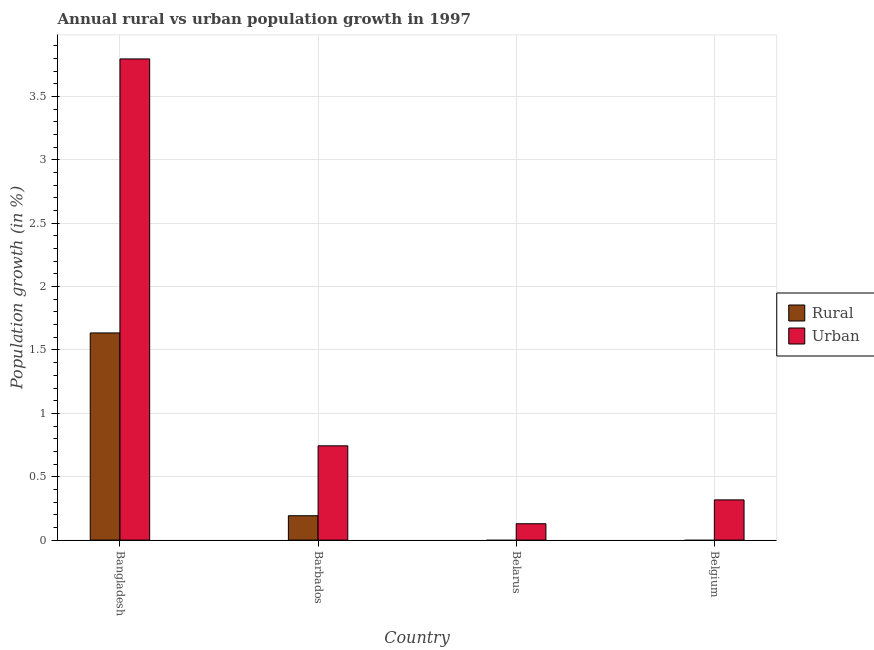How many different coloured bars are there?
Provide a short and direct response. 2. What is the label of the 2nd group of bars from the left?
Provide a short and direct response. Barbados. What is the rural population growth in Belgium?
Your answer should be compact. 0. Across all countries, what is the maximum urban population growth?
Make the answer very short. 3.8. In which country was the rural population growth maximum?
Your answer should be very brief. Bangladesh. What is the total urban population growth in the graph?
Give a very brief answer. 4.99. What is the difference between the urban population growth in Bangladesh and that in Barbados?
Your answer should be very brief. 3.05. What is the difference between the rural population growth in Belarus and the urban population growth in Belgium?
Keep it short and to the point. -0.32. What is the average urban population growth per country?
Your answer should be very brief. 1.25. What is the difference between the urban population growth and rural population growth in Bangladesh?
Keep it short and to the point. 2.16. What is the ratio of the rural population growth in Bangladesh to that in Barbados?
Your answer should be very brief. 8.5. What is the difference between the highest and the second highest urban population growth?
Offer a terse response. 3.05. What is the difference between the highest and the lowest rural population growth?
Your response must be concise. 1.63. In how many countries, is the urban population growth greater than the average urban population growth taken over all countries?
Your answer should be compact. 1. Is the sum of the urban population growth in Belarus and Belgium greater than the maximum rural population growth across all countries?
Provide a short and direct response. No. What is the difference between two consecutive major ticks on the Y-axis?
Ensure brevity in your answer.  0.5. Where does the legend appear in the graph?
Offer a very short reply. Center right. How many legend labels are there?
Your response must be concise. 2. How are the legend labels stacked?
Your answer should be very brief. Vertical. What is the title of the graph?
Keep it short and to the point. Annual rural vs urban population growth in 1997. Does "National Tourists" appear as one of the legend labels in the graph?
Give a very brief answer. No. What is the label or title of the X-axis?
Your answer should be compact. Country. What is the label or title of the Y-axis?
Keep it short and to the point. Population growth (in %). What is the Population growth (in %) in Rural in Bangladesh?
Give a very brief answer. 1.63. What is the Population growth (in %) in Urban  in Bangladesh?
Provide a succinct answer. 3.8. What is the Population growth (in %) in Rural in Barbados?
Your answer should be compact. 0.19. What is the Population growth (in %) of Urban  in Barbados?
Keep it short and to the point. 0.74. What is the Population growth (in %) of Urban  in Belarus?
Your response must be concise. 0.13. What is the Population growth (in %) of Rural in Belgium?
Your response must be concise. 0. What is the Population growth (in %) of Urban  in Belgium?
Make the answer very short. 0.32. Across all countries, what is the maximum Population growth (in %) of Rural?
Make the answer very short. 1.63. Across all countries, what is the maximum Population growth (in %) in Urban ?
Your answer should be very brief. 3.8. Across all countries, what is the minimum Population growth (in %) in Urban ?
Offer a terse response. 0.13. What is the total Population growth (in %) in Rural in the graph?
Provide a succinct answer. 1.83. What is the total Population growth (in %) in Urban  in the graph?
Give a very brief answer. 4.99. What is the difference between the Population growth (in %) of Rural in Bangladesh and that in Barbados?
Offer a terse response. 1.44. What is the difference between the Population growth (in %) in Urban  in Bangladesh and that in Barbados?
Provide a succinct answer. 3.05. What is the difference between the Population growth (in %) of Urban  in Bangladesh and that in Belarus?
Your answer should be very brief. 3.67. What is the difference between the Population growth (in %) in Urban  in Bangladesh and that in Belgium?
Ensure brevity in your answer.  3.48. What is the difference between the Population growth (in %) in Urban  in Barbados and that in Belarus?
Your answer should be very brief. 0.61. What is the difference between the Population growth (in %) of Urban  in Barbados and that in Belgium?
Offer a terse response. 0.43. What is the difference between the Population growth (in %) in Urban  in Belarus and that in Belgium?
Make the answer very short. -0.19. What is the difference between the Population growth (in %) of Rural in Bangladesh and the Population growth (in %) of Urban  in Barbados?
Provide a succinct answer. 0.89. What is the difference between the Population growth (in %) of Rural in Bangladesh and the Population growth (in %) of Urban  in Belarus?
Make the answer very short. 1.51. What is the difference between the Population growth (in %) of Rural in Bangladesh and the Population growth (in %) of Urban  in Belgium?
Provide a succinct answer. 1.32. What is the difference between the Population growth (in %) of Rural in Barbados and the Population growth (in %) of Urban  in Belarus?
Your answer should be very brief. 0.06. What is the difference between the Population growth (in %) in Rural in Barbados and the Population growth (in %) in Urban  in Belgium?
Provide a short and direct response. -0.12. What is the average Population growth (in %) of Rural per country?
Offer a terse response. 0.46. What is the average Population growth (in %) in Urban  per country?
Provide a short and direct response. 1.25. What is the difference between the Population growth (in %) of Rural and Population growth (in %) of Urban  in Bangladesh?
Give a very brief answer. -2.16. What is the difference between the Population growth (in %) of Rural and Population growth (in %) of Urban  in Barbados?
Your answer should be very brief. -0.55. What is the ratio of the Population growth (in %) in Rural in Bangladesh to that in Barbados?
Your answer should be very brief. 8.5. What is the ratio of the Population growth (in %) of Urban  in Bangladesh to that in Barbados?
Offer a terse response. 5.1. What is the ratio of the Population growth (in %) of Urban  in Bangladesh to that in Belarus?
Ensure brevity in your answer.  29.39. What is the ratio of the Population growth (in %) in Urban  in Bangladesh to that in Belgium?
Offer a terse response. 11.96. What is the ratio of the Population growth (in %) in Urban  in Barbados to that in Belarus?
Your response must be concise. 5.76. What is the ratio of the Population growth (in %) in Urban  in Barbados to that in Belgium?
Keep it short and to the point. 2.34. What is the ratio of the Population growth (in %) of Urban  in Belarus to that in Belgium?
Your response must be concise. 0.41. What is the difference between the highest and the second highest Population growth (in %) in Urban ?
Provide a succinct answer. 3.05. What is the difference between the highest and the lowest Population growth (in %) in Rural?
Provide a succinct answer. 1.63. What is the difference between the highest and the lowest Population growth (in %) in Urban ?
Provide a succinct answer. 3.67. 